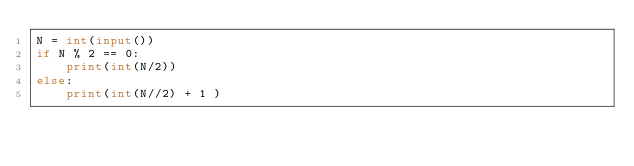Convert code to text. <code><loc_0><loc_0><loc_500><loc_500><_Python_>N = int(input())
if N % 2 == 0:
    print(int(N/2))
else:
    print(int(N//2) + 1 )</code> 